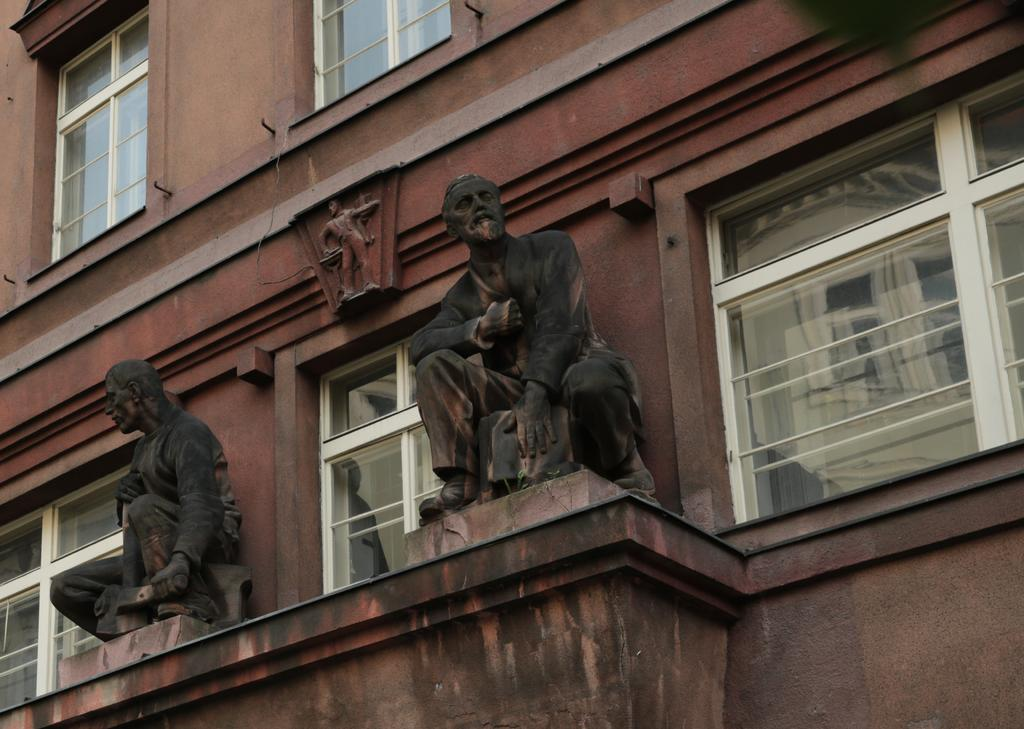What is the main structure visible in the image? There is a building in the image. What decorative elements can be seen on the building? There are statues on the wall of the building. What type of discussion is taking place in front of the building in the image? There is no discussion taking place in the image; it only shows a building with statues on the wall. 